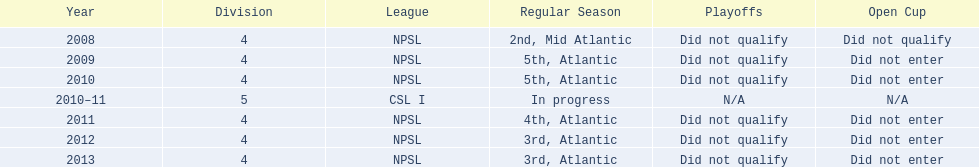Other than npsl, what league has ny mens soccer team played in? CSL I. 